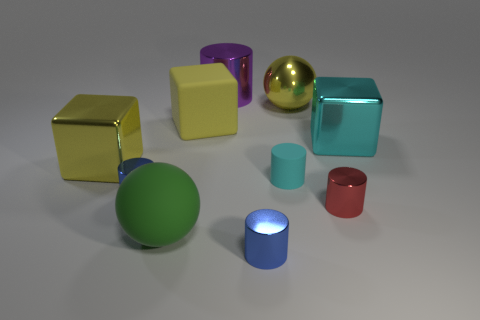Are there any other big cubes that have the same color as the large matte block?
Provide a short and direct response. Yes. There is a tiny matte thing; is it the same color as the big metallic cube right of the tiny rubber cylinder?
Provide a succinct answer. Yes. There is another cube that is the same color as the large rubber block; what material is it?
Your response must be concise. Metal. Does the large cylinder have the same color as the small rubber object?
Offer a terse response. No. How many other things are there of the same color as the matte cylinder?
Give a very brief answer. 1. Is the number of large rubber things that are in front of the red metal cylinder greater than the number of tiny things that are behind the large purple cylinder?
Offer a very short reply. Yes. How big is the matte sphere?
Give a very brief answer. Large. Is there a tiny cyan object of the same shape as the small red metal thing?
Your answer should be very brief. Yes. There is a cyan matte thing; is it the same shape as the yellow shiny object on the right side of the big purple thing?
Make the answer very short. No. There is a object that is both behind the big cyan metallic object and to the right of the large cylinder; what is its size?
Your response must be concise. Large. 